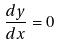Convert formula to latex. <formula><loc_0><loc_0><loc_500><loc_500>\frac { d y } { d x } = 0</formula> 